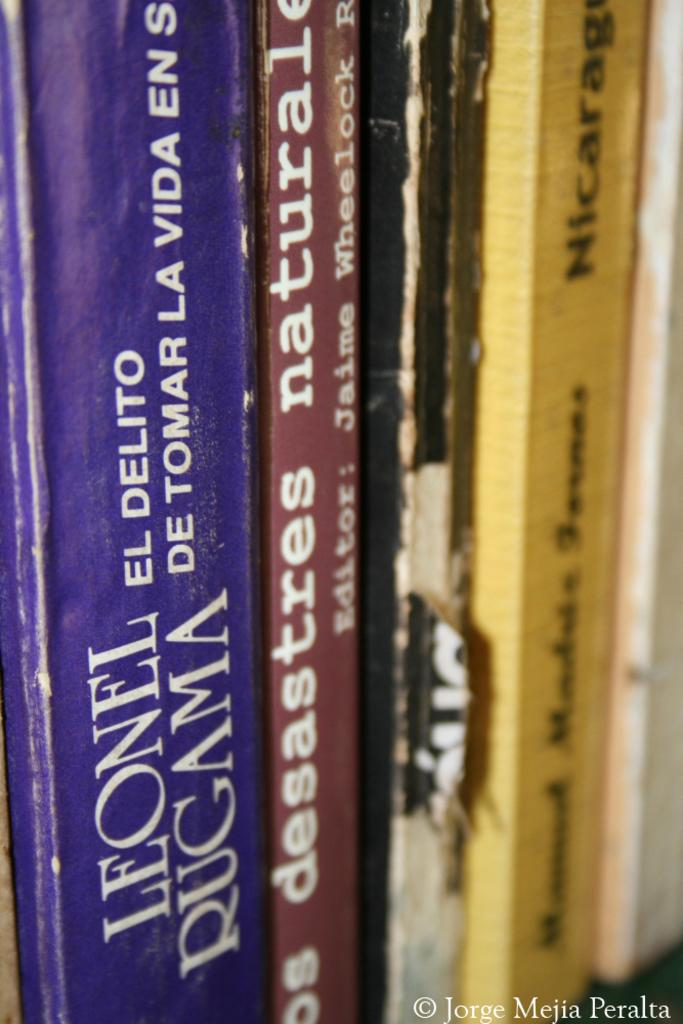<image>
Relay a brief, clear account of the picture shown. Books on a shelf with the terms Leonel Rugama. 